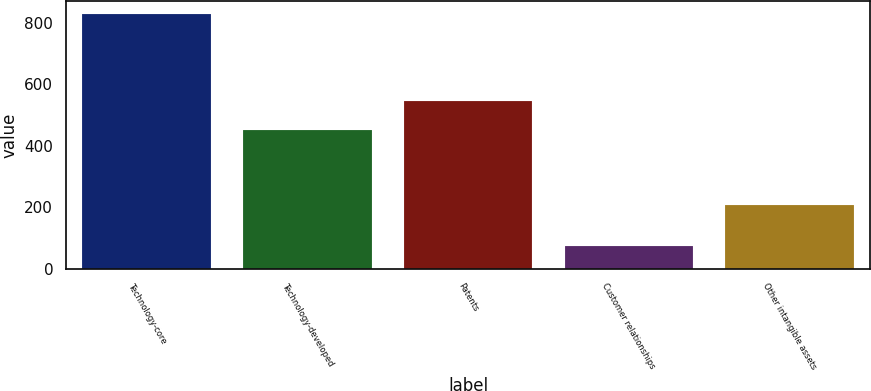Convert chart to OTSL. <chart><loc_0><loc_0><loc_500><loc_500><bar_chart><fcel>Technology-core<fcel>Technology-developed<fcel>Patents<fcel>Customer relationships<fcel>Other intangible assets<nl><fcel>829<fcel>453<fcel>547<fcel>73<fcel>208<nl></chart> 